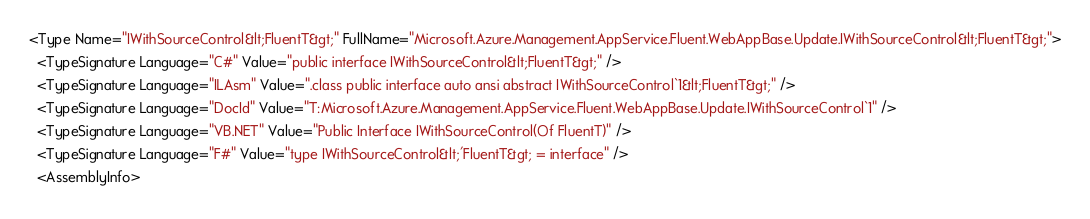<code> <loc_0><loc_0><loc_500><loc_500><_XML_><Type Name="IWithSourceControl&lt;FluentT&gt;" FullName="Microsoft.Azure.Management.AppService.Fluent.WebAppBase.Update.IWithSourceControl&lt;FluentT&gt;">
  <TypeSignature Language="C#" Value="public interface IWithSourceControl&lt;FluentT&gt;" />
  <TypeSignature Language="ILAsm" Value=".class public interface auto ansi abstract IWithSourceControl`1&lt;FluentT&gt;" />
  <TypeSignature Language="DocId" Value="T:Microsoft.Azure.Management.AppService.Fluent.WebAppBase.Update.IWithSourceControl`1" />
  <TypeSignature Language="VB.NET" Value="Public Interface IWithSourceControl(Of FluentT)" />
  <TypeSignature Language="F#" Value="type IWithSourceControl&lt;'FluentT&gt; = interface" />
  <AssemblyInfo></code> 